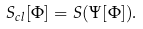<formula> <loc_0><loc_0><loc_500><loc_500>S _ { c l } [ \Phi ] = S ( \Psi [ \Phi ] ) .</formula> 